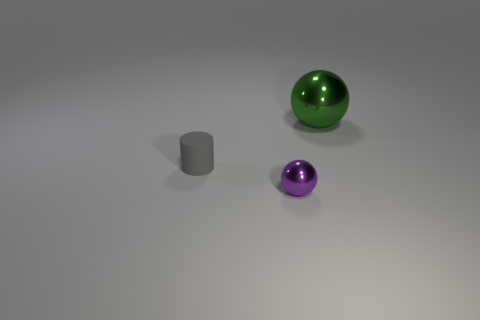Add 3 big gray shiny blocks. How many objects exist? 6 Subtract all spheres. How many objects are left? 1 Add 3 purple shiny objects. How many purple shiny objects exist? 4 Subtract 0 yellow cylinders. How many objects are left? 3 Subtract all tiny gray things. Subtract all green shiny things. How many objects are left? 1 Add 3 small purple metal spheres. How many small purple metal spheres are left? 4 